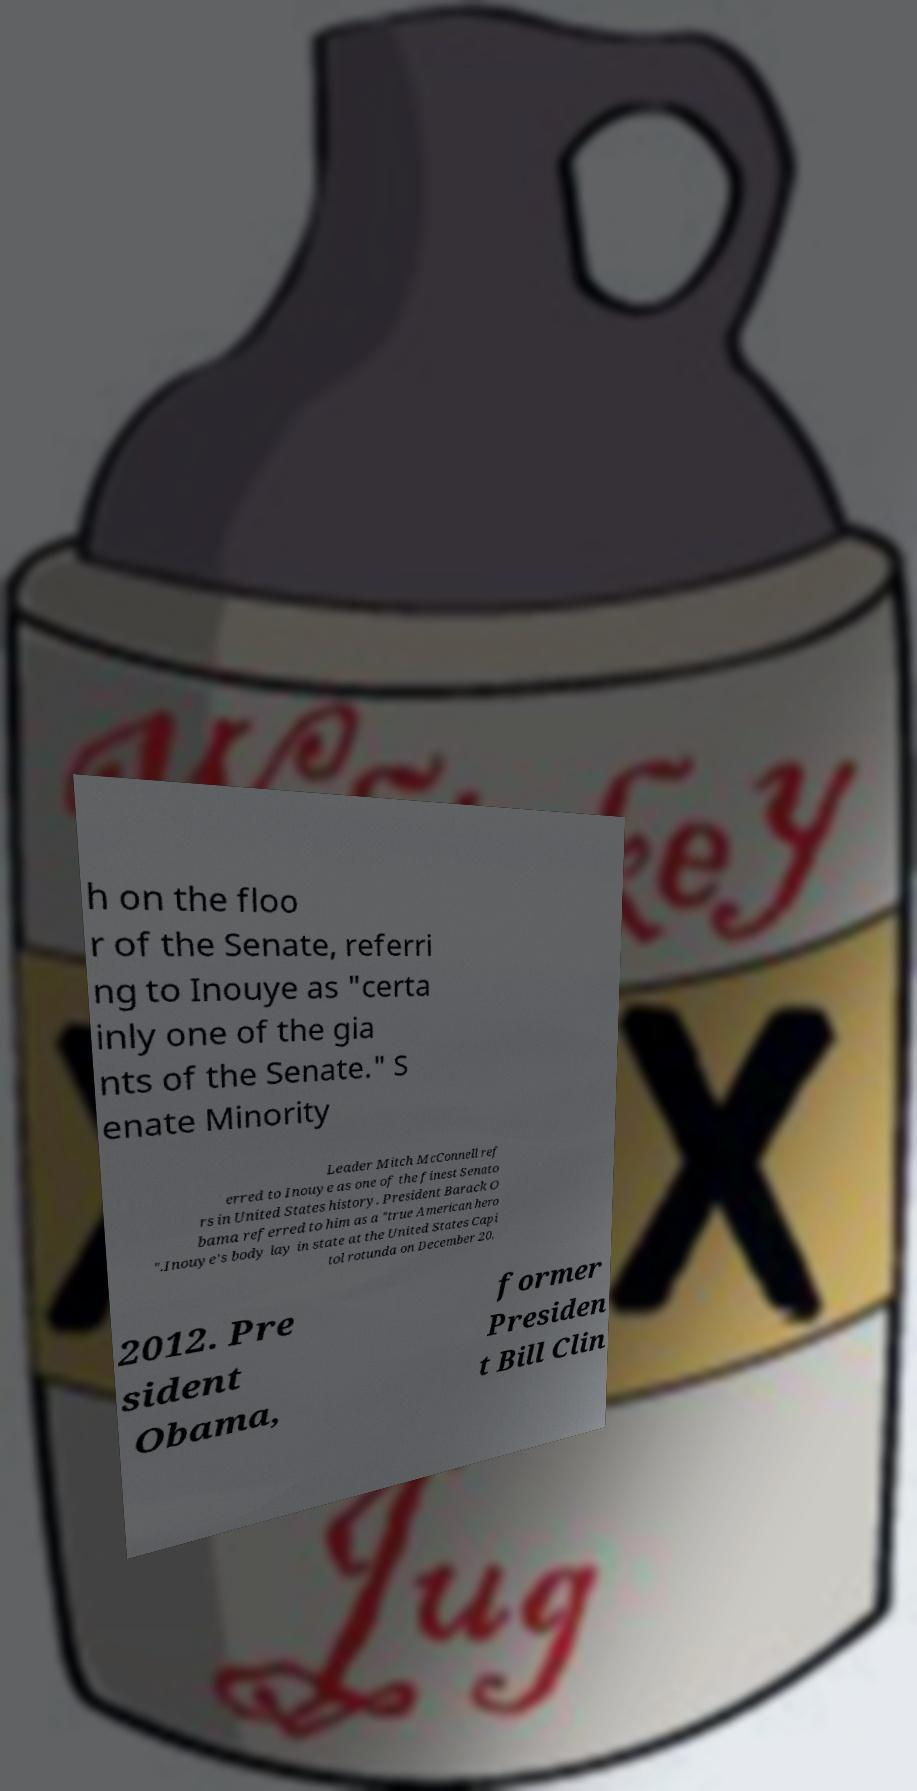I need the written content from this picture converted into text. Can you do that? h on the floo r of the Senate, referri ng to Inouye as "certa inly one of the gia nts of the Senate." S enate Minority Leader Mitch McConnell ref erred to Inouye as one of the finest Senato rs in United States history. President Barack O bama referred to him as a "true American hero ".Inouye's body lay in state at the United States Capi tol rotunda on December 20, 2012. Pre sident Obama, former Presiden t Bill Clin 